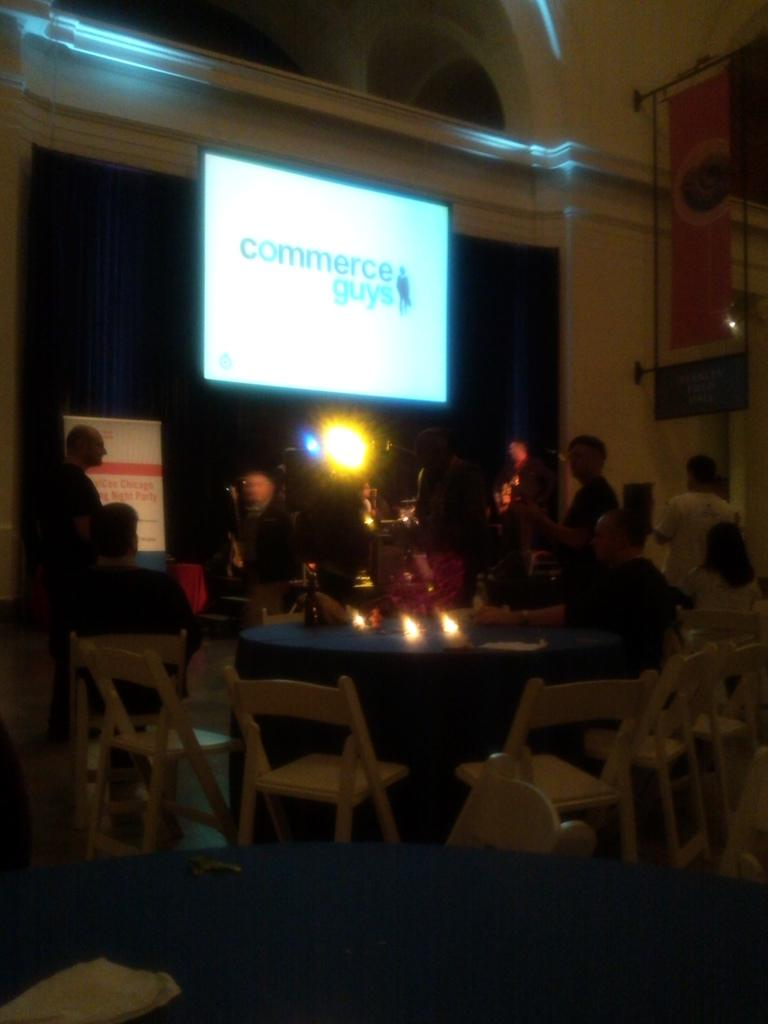What type of establishment is the image taken in? The image appears to be taken in a restaurant. What activity is happening in the image? A meeting is taking place in the image. What furniture is present in the image? There are dining tables and chairs in the image. Can you describe the people in the image? There are people standing in front in the image. What musical instrument is being played by the people in the image? There is no musical instrument being played in the image; the people are attending a meeting. Can you see any rays of light coming from the ceiling in the image? There is no mention of rays of light in the image; the focus is on the meeting and the restaurant setting. 